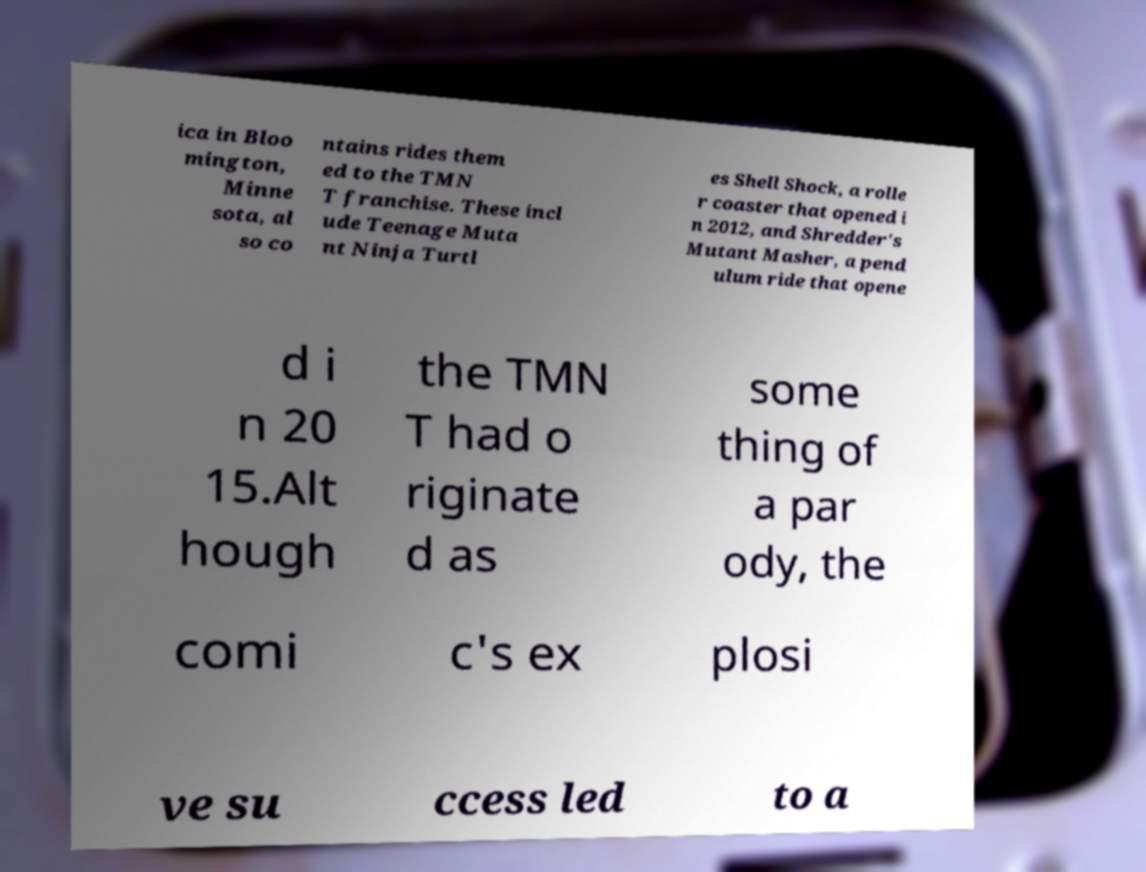Please read and relay the text visible in this image. What does it say? ica in Bloo mington, Minne sota, al so co ntains rides them ed to the TMN T franchise. These incl ude Teenage Muta nt Ninja Turtl es Shell Shock, a rolle r coaster that opened i n 2012, and Shredder's Mutant Masher, a pend ulum ride that opene d i n 20 15.Alt hough the TMN T had o riginate d as some thing of a par ody, the comi c's ex plosi ve su ccess led to a 